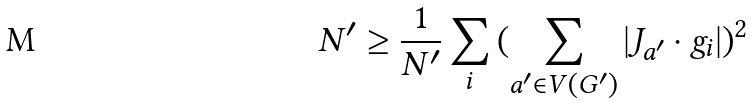Convert formula to latex. <formula><loc_0><loc_0><loc_500><loc_500>N ^ { \prime } \geq { \frac { 1 } { N ^ { \prime } } } \sum _ { i } { ( \sum _ { a ^ { \prime } \in V ( G ^ { \prime } ) } { | J _ { a ^ { \prime } } \cdot g _ { i } | } ) ^ { 2 } }</formula> 